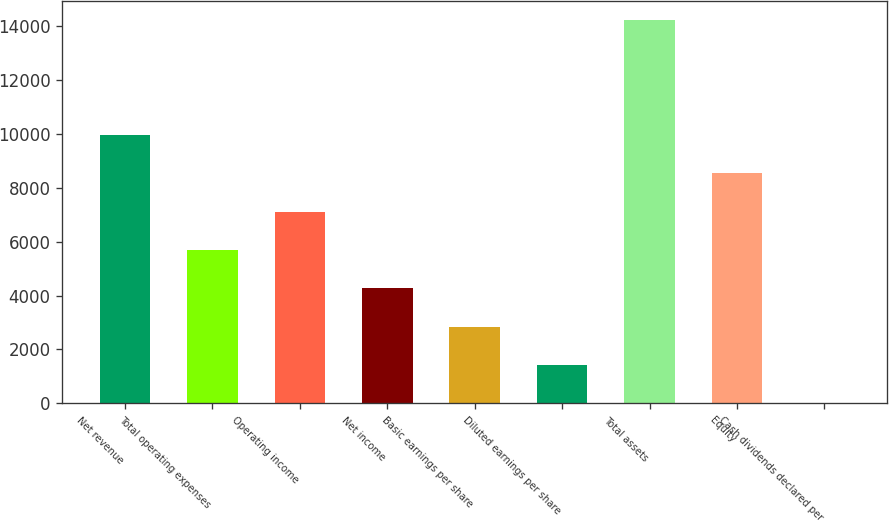Convert chart. <chart><loc_0><loc_0><loc_500><loc_500><bar_chart><fcel>Net revenue<fcel>Total operating expenses<fcel>Operating income<fcel>Net income<fcel>Basic earnings per share<fcel>Diluted earnings per share<fcel>Total assets<fcel>Equity<fcel>Cash dividends declared per<nl><fcel>9969.48<fcel>5696.97<fcel>7121.14<fcel>4272.8<fcel>2848.63<fcel>1424.46<fcel>14242<fcel>8545.31<fcel>0.29<nl></chart> 